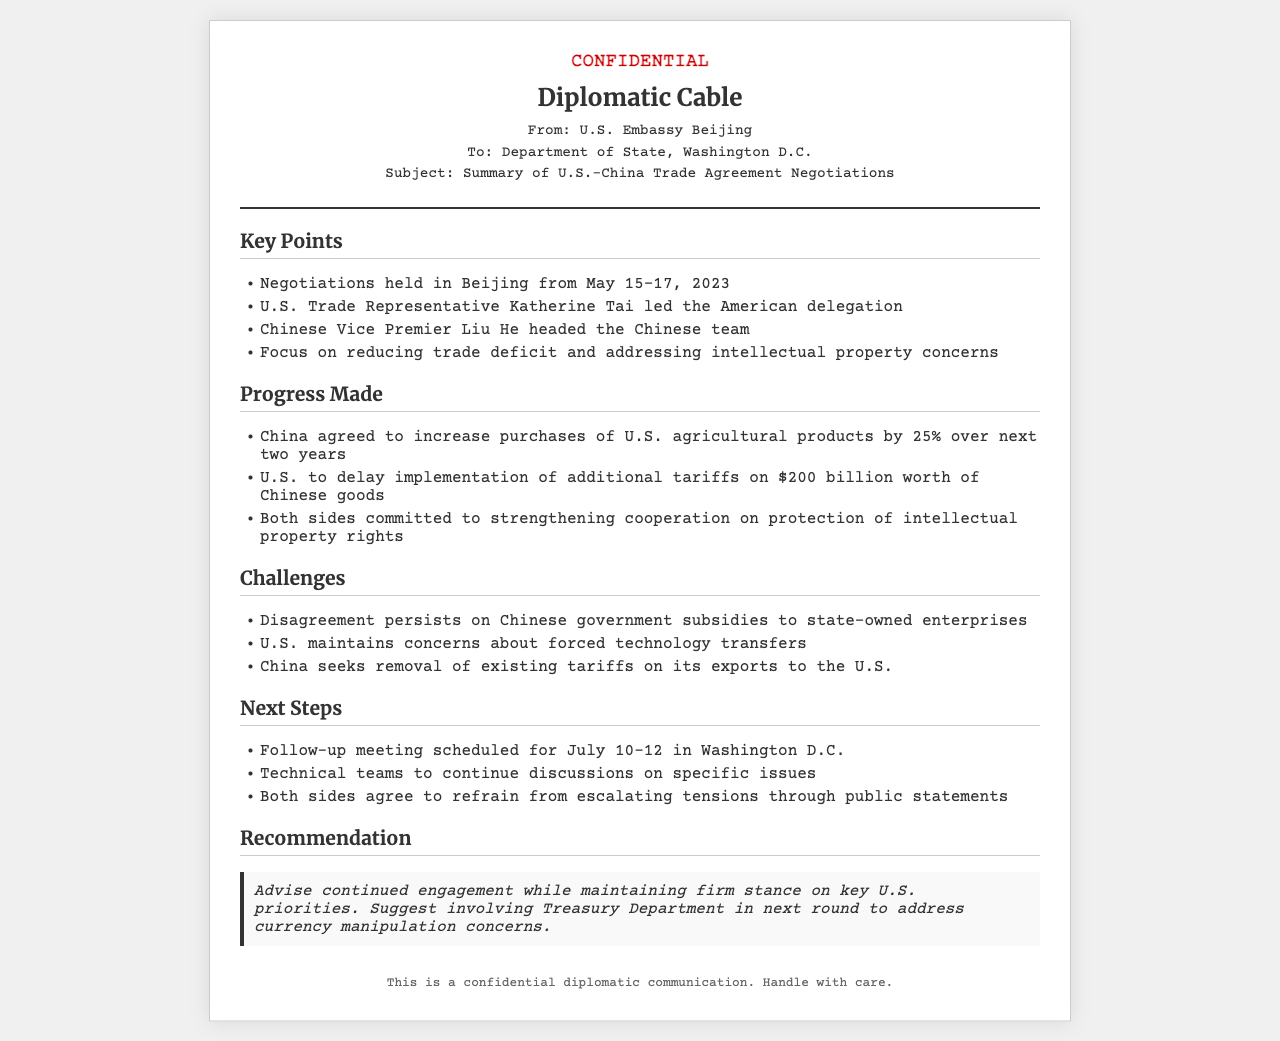What were the dates of the negotiations? The dates of the negotiations held in Beijing are specifically mentioned as May 15-17, 2023.
Answer: May 15-17, 2023 Who led the U.S. delegation? The document states that the U.S. Trade Representative Katherine Tai led the American delegation during the negotiations.
Answer: Katherine Tai What percentage increase in agricultural product purchases did China agree to? The agreement states that China will increase purchases of U.S. agricultural products by 25% over the next two years.
Answer: 25% What is the next scheduled meeting date? The document indicates that the follow-up meeting is set for July 10-12 in Washington D.C.
Answer: July 10-12 What major issue remains a disagreement? The document points out that disagreement persists regarding Chinese government subsidies to state-owned enterprises.
Answer: Chinese government subsidies What is the recommendation provided in the cable? The recommendation suggests continued engagement while maintaining a firm stance on key U.S. priorities.
Answer: Continued engagement Who headed the Chinese team? The document specifies that Chinese Vice Premier Liu He was in charge of the Chinese team during negotiations.
Answer: Liu He What is one of the U.S. concerns regarding China? The document mentions that the U.S. has concerns about forced technology transfers from China.
Answer: Forced technology transfers 